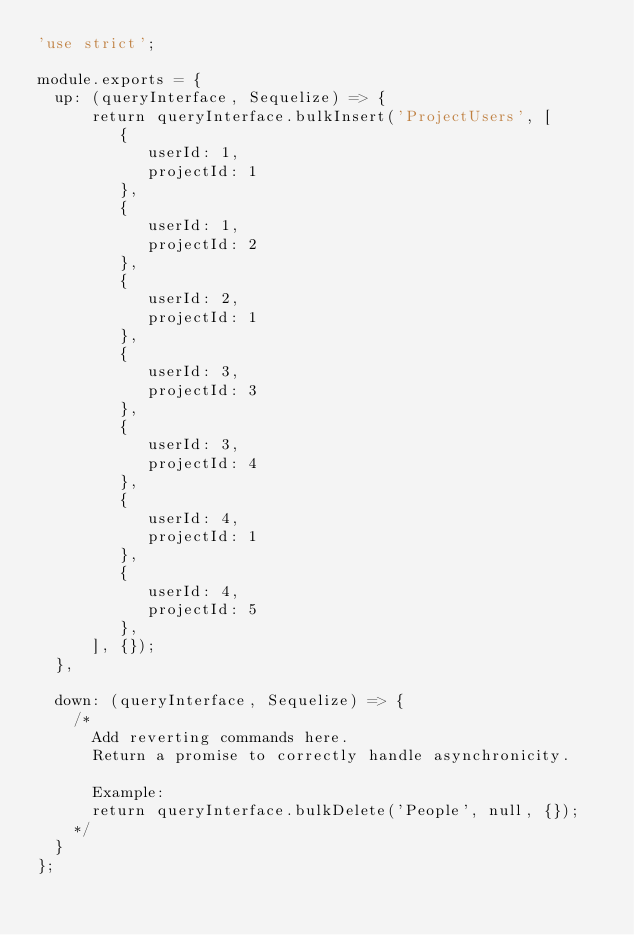<code> <loc_0><loc_0><loc_500><loc_500><_JavaScript_>'use strict';

module.exports = {
  up: (queryInterface, Sequelize) => {
      return queryInterface.bulkInsert('ProjectUsers', [
         {
            userId: 1,
            projectId: 1
         },
         {
            userId: 1,
            projectId: 2
         },
         {
            userId: 2,
            projectId: 1
         },
         {
            userId: 3,
            projectId: 3
         },
         {
            userId: 3,
            projectId: 4
         },
         {
            userId: 4,
            projectId: 1
         },
         {
            userId: 4,
            projectId: 5
         },
      ], {});
  },

  down: (queryInterface, Sequelize) => {
    /*
      Add reverting commands here.
      Return a promise to correctly handle asynchronicity.

      Example:
      return queryInterface.bulkDelete('People', null, {});
    */
  }
};
</code> 